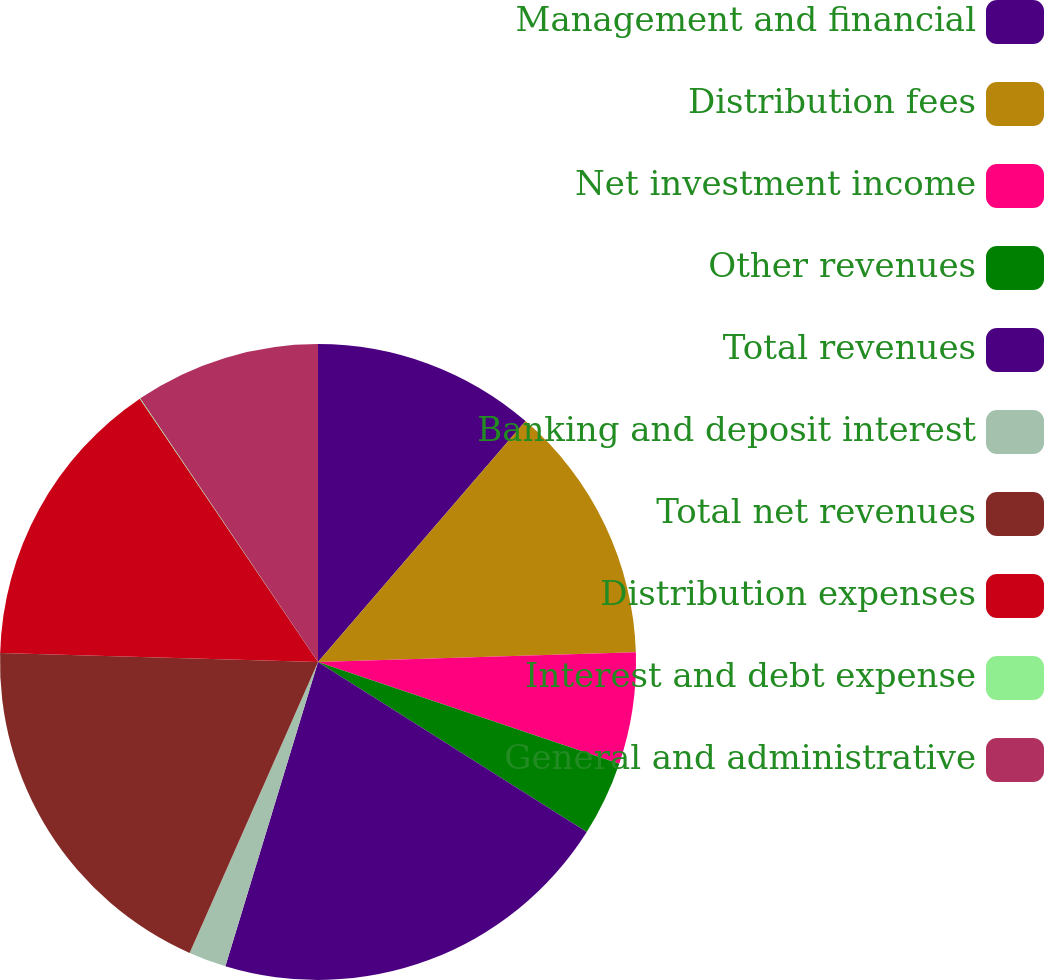Convert chart. <chart><loc_0><loc_0><loc_500><loc_500><pie_chart><fcel>Management and financial<fcel>Distribution fees<fcel>Net investment income<fcel>Other revenues<fcel>Total revenues<fcel>Banking and deposit interest<fcel>Total net revenues<fcel>Distribution expenses<fcel>Interest and debt expense<fcel>General and administrative<nl><fcel>11.32%<fcel>13.2%<fcel>5.67%<fcel>3.79%<fcel>20.73%<fcel>1.91%<fcel>18.84%<fcel>15.08%<fcel>0.03%<fcel>9.44%<nl></chart> 